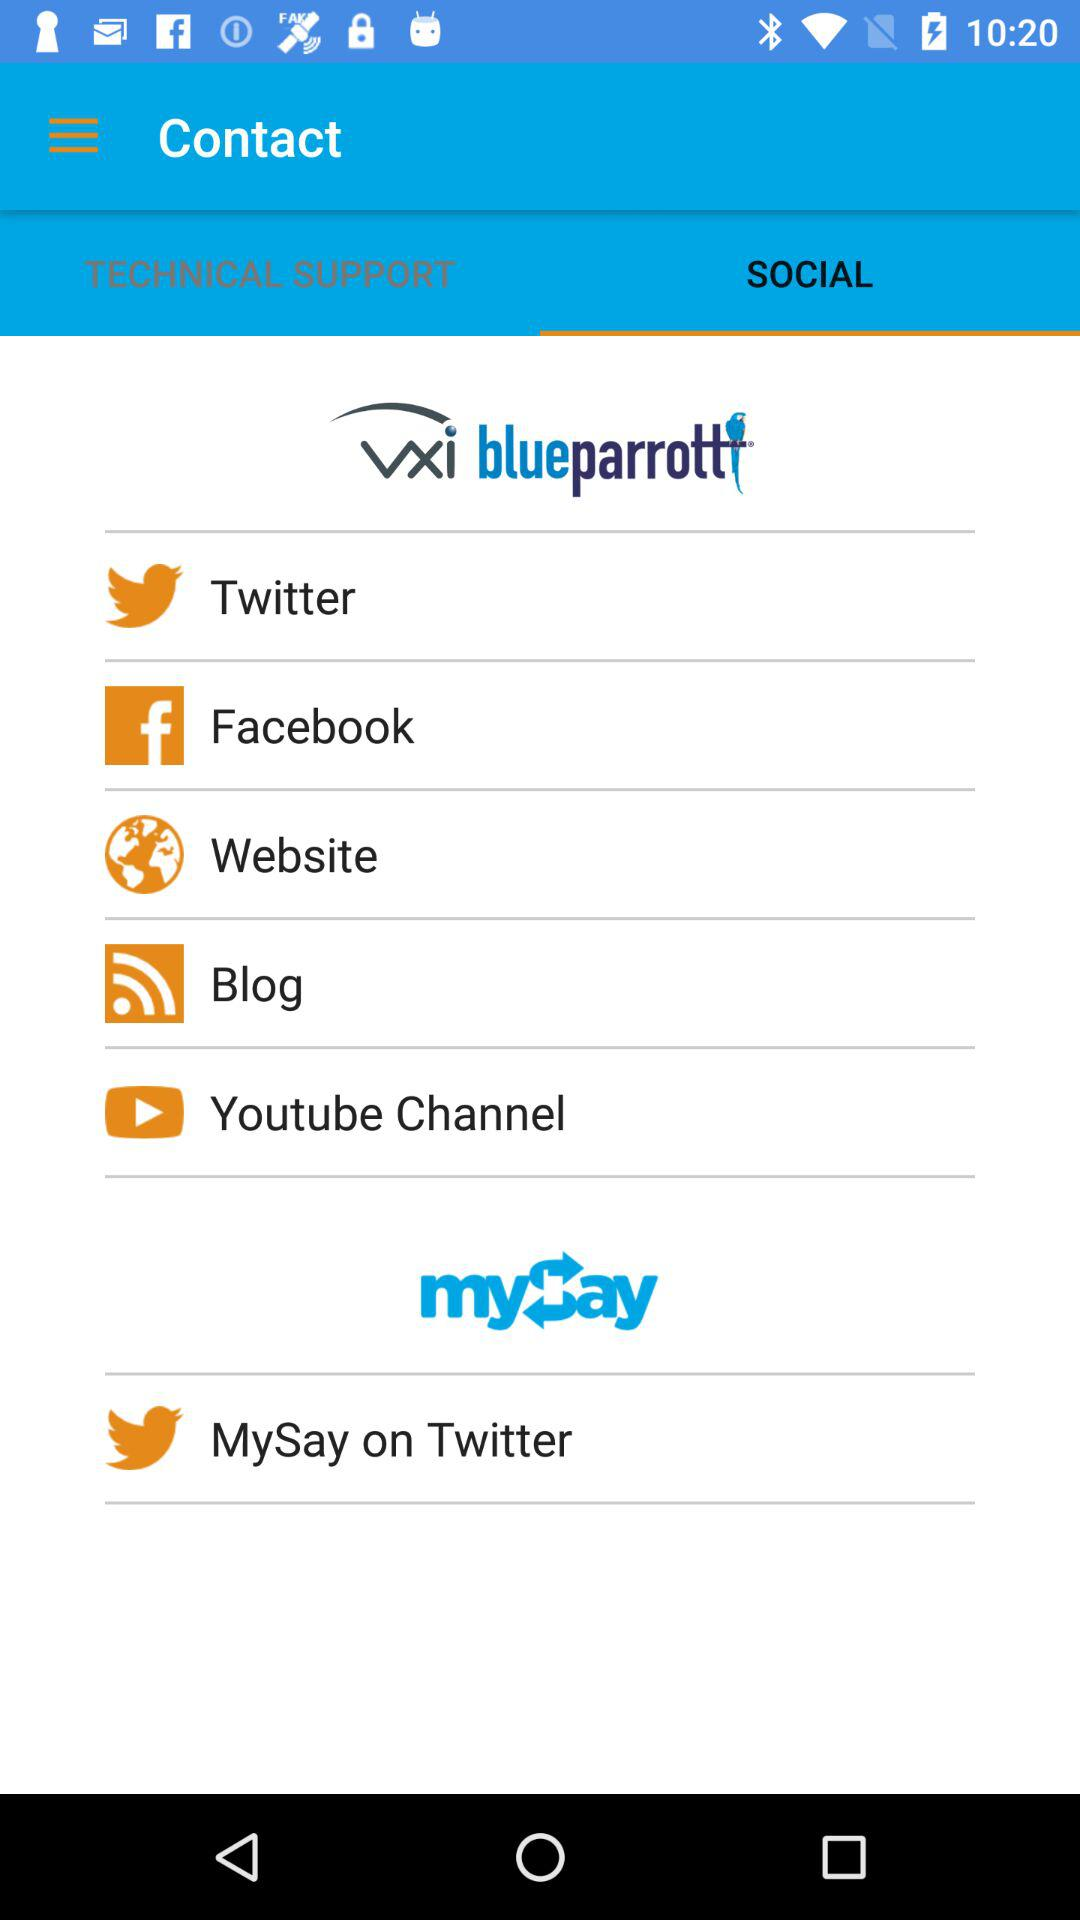What is the selected library in contact?
When the provided information is insufficient, respond with <no answer>. <no answer> 